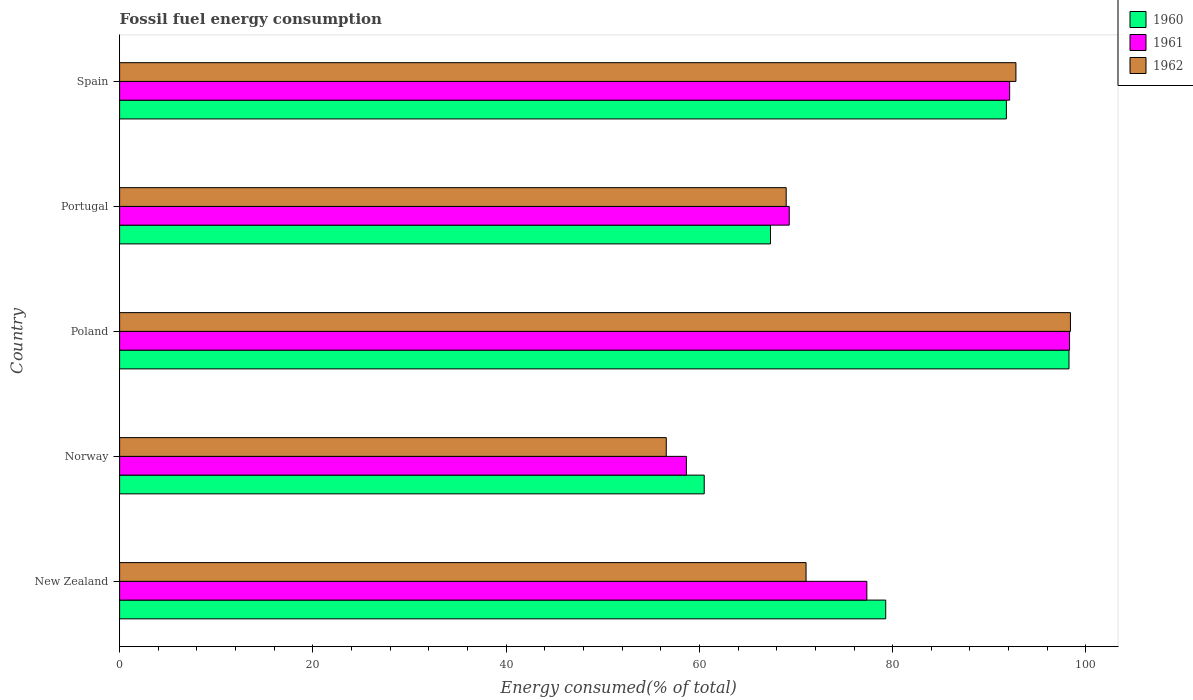How many different coloured bars are there?
Make the answer very short. 3. How many groups of bars are there?
Your answer should be compact. 5. Are the number of bars per tick equal to the number of legend labels?
Offer a terse response. Yes. How many bars are there on the 5th tick from the top?
Your answer should be very brief. 3. What is the label of the 1st group of bars from the top?
Keep it short and to the point. Spain. In how many cases, is the number of bars for a given country not equal to the number of legend labels?
Ensure brevity in your answer.  0. What is the percentage of energy consumed in 1961 in Norway?
Give a very brief answer. 58.65. Across all countries, what is the maximum percentage of energy consumed in 1962?
Your answer should be compact. 98.4. Across all countries, what is the minimum percentage of energy consumed in 1962?
Offer a terse response. 56.57. What is the total percentage of energy consumed in 1960 in the graph?
Provide a short and direct response. 397.15. What is the difference between the percentage of energy consumed in 1962 in New Zealand and that in Norway?
Provide a short and direct response. 14.47. What is the difference between the percentage of energy consumed in 1961 in Spain and the percentage of energy consumed in 1962 in Norway?
Provide a short and direct response. 35.53. What is the average percentage of energy consumed in 1962 per country?
Your answer should be compact. 77.55. What is the difference between the percentage of energy consumed in 1962 and percentage of energy consumed in 1961 in Norway?
Give a very brief answer. -2.08. What is the ratio of the percentage of energy consumed in 1962 in New Zealand to that in Spain?
Ensure brevity in your answer.  0.77. Is the difference between the percentage of energy consumed in 1962 in New Zealand and Norway greater than the difference between the percentage of energy consumed in 1961 in New Zealand and Norway?
Offer a very short reply. No. What is the difference between the highest and the second highest percentage of energy consumed in 1960?
Offer a very short reply. 6.48. What is the difference between the highest and the lowest percentage of energy consumed in 1962?
Make the answer very short. 41.83. In how many countries, is the percentage of energy consumed in 1962 greater than the average percentage of energy consumed in 1962 taken over all countries?
Make the answer very short. 2. What does the 3rd bar from the top in Norway represents?
Your answer should be very brief. 1960. What does the 1st bar from the bottom in Poland represents?
Offer a very short reply. 1960. Is it the case that in every country, the sum of the percentage of energy consumed in 1960 and percentage of energy consumed in 1962 is greater than the percentage of energy consumed in 1961?
Give a very brief answer. Yes. Are all the bars in the graph horizontal?
Give a very brief answer. Yes. How many countries are there in the graph?
Your response must be concise. 5. What is the difference between two consecutive major ticks on the X-axis?
Offer a very short reply. 20. Where does the legend appear in the graph?
Offer a very short reply. Top right. What is the title of the graph?
Keep it short and to the point. Fossil fuel energy consumption. Does "1974" appear as one of the legend labels in the graph?
Offer a very short reply. No. What is the label or title of the X-axis?
Keep it short and to the point. Energy consumed(% of total). What is the Energy consumed(% of total) of 1960 in New Zealand?
Make the answer very short. 79.28. What is the Energy consumed(% of total) in 1961 in New Zealand?
Provide a short and direct response. 77.33. What is the Energy consumed(% of total) of 1962 in New Zealand?
Provide a short and direct response. 71.04. What is the Energy consumed(% of total) in 1960 in Norway?
Your answer should be very brief. 60.5. What is the Energy consumed(% of total) of 1961 in Norway?
Ensure brevity in your answer.  58.65. What is the Energy consumed(% of total) in 1962 in Norway?
Your answer should be compact. 56.57. What is the Energy consumed(% of total) in 1960 in Poland?
Ensure brevity in your answer.  98.25. What is the Energy consumed(% of total) in 1961 in Poland?
Provide a short and direct response. 98.3. What is the Energy consumed(% of total) of 1962 in Poland?
Provide a short and direct response. 98.4. What is the Energy consumed(% of total) in 1960 in Portugal?
Ensure brevity in your answer.  67.36. What is the Energy consumed(% of total) of 1961 in Portugal?
Keep it short and to the point. 69.3. What is the Energy consumed(% of total) in 1962 in Portugal?
Offer a very short reply. 68.98. What is the Energy consumed(% of total) in 1960 in Spain?
Ensure brevity in your answer.  91.77. What is the Energy consumed(% of total) of 1961 in Spain?
Keep it short and to the point. 92.1. What is the Energy consumed(% of total) of 1962 in Spain?
Offer a terse response. 92.75. Across all countries, what is the maximum Energy consumed(% of total) in 1960?
Keep it short and to the point. 98.25. Across all countries, what is the maximum Energy consumed(% of total) in 1961?
Give a very brief answer. 98.3. Across all countries, what is the maximum Energy consumed(% of total) in 1962?
Provide a succinct answer. 98.4. Across all countries, what is the minimum Energy consumed(% of total) in 1960?
Offer a terse response. 60.5. Across all countries, what is the minimum Energy consumed(% of total) in 1961?
Provide a succinct answer. 58.65. Across all countries, what is the minimum Energy consumed(% of total) in 1962?
Make the answer very short. 56.57. What is the total Energy consumed(% of total) in 1960 in the graph?
Provide a short and direct response. 397.14. What is the total Energy consumed(% of total) in 1961 in the graph?
Offer a very short reply. 395.68. What is the total Energy consumed(% of total) in 1962 in the graph?
Provide a succinct answer. 387.74. What is the difference between the Energy consumed(% of total) in 1960 in New Zealand and that in Norway?
Offer a terse response. 18.78. What is the difference between the Energy consumed(% of total) in 1961 in New Zealand and that in Norway?
Your response must be concise. 18.68. What is the difference between the Energy consumed(% of total) of 1962 in New Zealand and that in Norway?
Offer a terse response. 14.47. What is the difference between the Energy consumed(% of total) of 1960 in New Zealand and that in Poland?
Offer a terse response. -18.97. What is the difference between the Energy consumed(% of total) in 1961 in New Zealand and that in Poland?
Offer a very short reply. -20.98. What is the difference between the Energy consumed(% of total) of 1962 in New Zealand and that in Poland?
Give a very brief answer. -27.36. What is the difference between the Energy consumed(% of total) in 1960 in New Zealand and that in Portugal?
Your response must be concise. 11.92. What is the difference between the Energy consumed(% of total) of 1961 in New Zealand and that in Portugal?
Ensure brevity in your answer.  8.03. What is the difference between the Energy consumed(% of total) of 1962 in New Zealand and that in Portugal?
Make the answer very short. 2.06. What is the difference between the Energy consumed(% of total) of 1960 in New Zealand and that in Spain?
Provide a short and direct response. -12.49. What is the difference between the Energy consumed(% of total) of 1961 in New Zealand and that in Spain?
Give a very brief answer. -14.78. What is the difference between the Energy consumed(% of total) of 1962 in New Zealand and that in Spain?
Provide a short and direct response. -21.72. What is the difference between the Energy consumed(% of total) of 1960 in Norway and that in Poland?
Your response must be concise. -37.75. What is the difference between the Energy consumed(% of total) of 1961 in Norway and that in Poland?
Your response must be concise. -39.65. What is the difference between the Energy consumed(% of total) of 1962 in Norway and that in Poland?
Offer a terse response. -41.83. What is the difference between the Energy consumed(% of total) in 1960 in Norway and that in Portugal?
Keep it short and to the point. -6.86. What is the difference between the Energy consumed(% of total) of 1961 in Norway and that in Portugal?
Provide a short and direct response. -10.64. What is the difference between the Energy consumed(% of total) of 1962 in Norway and that in Portugal?
Your answer should be very brief. -12.41. What is the difference between the Energy consumed(% of total) of 1960 in Norway and that in Spain?
Give a very brief answer. -31.27. What is the difference between the Energy consumed(% of total) of 1961 in Norway and that in Spain?
Make the answer very short. -33.45. What is the difference between the Energy consumed(% of total) of 1962 in Norway and that in Spain?
Ensure brevity in your answer.  -36.18. What is the difference between the Energy consumed(% of total) in 1960 in Poland and that in Portugal?
Offer a terse response. 30.89. What is the difference between the Energy consumed(% of total) of 1961 in Poland and that in Portugal?
Your response must be concise. 29.01. What is the difference between the Energy consumed(% of total) in 1962 in Poland and that in Portugal?
Your answer should be very brief. 29.42. What is the difference between the Energy consumed(% of total) of 1960 in Poland and that in Spain?
Provide a succinct answer. 6.48. What is the difference between the Energy consumed(% of total) in 1961 in Poland and that in Spain?
Provide a short and direct response. 6.2. What is the difference between the Energy consumed(% of total) of 1962 in Poland and that in Spain?
Make the answer very short. 5.64. What is the difference between the Energy consumed(% of total) of 1960 in Portugal and that in Spain?
Ensure brevity in your answer.  -24.41. What is the difference between the Energy consumed(% of total) of 1961 in Portugal and that in Spain?
Make the answer very short. -22.81. What is the difference between the Energy consumed(% of total) in 1962 in Portugal and that in Spain?
Your response must be concise. -23.77. What is the difference between the Energy consumed(% of total) of 1960 in New Zealand and the Energy consumed(% of total) of 1961 in Norway?
Your response must be concise. 20.63. What is the difference between the Energy consumed(% of total) in 1960 in New Zealand and the Energy consumed(% of total) in 1962 in Norway?
Your response must be concise. 22.71. What is the difference between the Energy consumed(% of total) in 1961 in New Zealand and the Energy consumed(% of total) in 1962 in Norway?
Ensure brevity in your answer.  20.76. What is the difference between the Energy consumed(% of total) of 1960 in New Zealand and the Energy consumed(% of total) of 1961 in Poland?
Give a very brief answer. -19.02. What is the difference between the Energy consumed(% of total) in 1960 in New Zealand and the Energy consumed(% of total) in 1962 in Poland?
Offer a terse response. -19.12. What is the difference between the Energy consumed(% of total) in 1961 in New Zealand and the Energy consumed(% of total) in 1962 in Poland?
Offer a very short reply. -21.07. What is the difference between the Energy consumed(% of total) in 1960 in New Zealand and the Energy consumed(% of total) in 1961 in Portugal?
Give a very brief answer. 9.98. What is the difference between the Energy consumed(% of total) of 1960 in New Zealand and the Energy consumed(% of total) of 1962 in Portugal?
Give a very brief answer. 10.3. What is the difference between the Energy consumed(% of total) of 1961 in New Zealand and the Energy consumed(% of total) of 1962 in Portugal?
Keep it short and to the point. 8.35. What is the difference between the Energy consumed(% of total) of 1960 in New Zealand and the Energy consumed(% of total) of 1961 in Spain?
Your answer should be compact. -12.83. What is the difference between the Energy consumed(% of total) in 1960 in New Zealand and the Energy consumed(% of total) in 1962 in Spain?
Offer a very short reply. -13.47. What is the difference between the Energy consumed(% of total) in 1961 in New Zealand and the Energy consumed(% of total) in 1962 in Spain?
Make the answer very short. -15.43. What is the difference between the Energy consumed(% of total) in 1960 in Norway and the Energy consumed(% of total) in 1961 in Poland?
Your answer should be compact. -37.81. What is the difference between the Energy consumed(% of total) in 1960 in Norway and the Energy consumed(% of total) in 1962 in Poland?
Your answer should be compact. -37.9. What is the difference between the Energy consumed(% of total) of 1961 in Norway and the Energy consumed(% of total) of 1962 in Poland?
Offer a very short reply. -39.74. What is the difference between the Energy consumed(% of total) of 1960 in Norway and the Energy consumed(% of total) of 1961 in Portugal?
Provide a succinct answer. -8.8. What is the difference between the Energy consumed(% of total) of 1960 in Norway and the Energy consumed(% of total) of 1962 in Portugal?
Make the answer very short. -8.48. What is the difference between the Energy consumed(% of total) of 1961 in Norway and the Energy consumed(% of total) of 1962 in Portugal?
Provide a succinct answer. -10.33. What is the difference between the Energy consumed(% of total) of 1960 in Norway and the Energy consumed(% of total) of 1961 in Spain?
Give a very brief answer. -31.61. What is the difference between the Energy consumed(% of total) of 1960 in Norway and the Energy consumed(% of total) of 1962 in Spain?
Provide a short and direct response. -32.26. What is the difference between the Energy consumed(% of total) in 1961 in Norway and the Energy consumed(% of total) in 1962 in Spain?
Your answer should be very brief. -34.1. What is the difference between the Energy consumed(% of total) of 1960 in Poland and the Energy consumed(% of total) of 1961 in Portugal?
Give a very brief answer. 28.95. What is the difference between the Energy consumed(% of total) of 1960 in Poland and the Energy consumed(% of total) of 1962 in Portugal?
Your answer should be compact. 29.27. What is the difference between the Energy consumed(% of total) of 1961 in Poland and the Energy consumed(% of total) of 1962 in Portugal?
Your answer should be compact. 29.32. What is the difference between the Energy consumed(% of total) of 1960 in Poland and the Energy consumed(% of total) of 1961 in Spain?
Offer a very short reply. 6.14. What is the difference between the Energy consumed(% of total) of 1960 in Poland and the Energy consumed(% of total) of 1962 in Spain?
Give a very brief answer. 5.49. What is the difference between the Energy consumed(% of total) of 1961 in Poland and the Energy consumed(% of total) of 1962 in Spain?
Offer a very short reply. 5.55. What is the difference between the Energy consumed(% of total) of 1960 in Portugal and the Energy consumed(% of total) of 1961 in Spain?
Offer a terse response. -24.75. What is the difference between the Energy consumed(% of total) in 1960 in Portugal and the Energy consumed(% of total) in 1962 in Spain?
Provide a short and direct response. -25.4. What is the difference between the Energy consumed(% of total) in 1961 in Portugal and the Energy consumed(% of total) in 1962 in Spain?
Your response must be concise. -23.46. What is the average Energy consumed(% of total) in 1960 per country?
Keep it short and to the point. 79.43. What is the average Energy consumed(% of total) of 1961 per country?
Your answer should be compact. 79.14. What is the average Energy consumed(% of total) in 1962 per country?
Give a very brief answer. 77.55. What is the difference between the Energy consumed(% of total) in 1960 and Energy consumed(% of total) in 1961 in New Zealand?
Your response must be concise. 1.95. What is the difference between the Energy consumed(% of total) of 1960 and Energy consumed(% of total) of 1962 in New Zealand?
Offer a terse response. 8.24. What is the difference between the Energy consumed(% of total) of 1961 and Energy consumed(% of total) of 1962 in New Zealand?
Your answer should be very brief. 6.29. What is the difference between the Energy consumed(% of total) of 1960 and Energy consumed(% of total) of 1961 in Norway?
Offer a very short reply. 1.85. What is the difference between the Energy consumed(% of total) of 1960 and Energy consumed(% of total) of 1962 in Norway?
Give a very brief answer. 3.93. What is the difference between the Energy consumed(% of total) in 1961 and Energy consumed(% of total) in 1962 in Norway?
Keep it short and to the point. 2.08. What is the difference between the Energy consumed(% of total) in 1960 and Energy consumed(% of total) in 1961 in Poland?
Make the answer very short. -0.06. What is the difference between the Energy consumed(% of total) in 1960 and Energy consumed(% of total) in 1962 in Poland?
Give a very brief answer. -0.15. What is the difference between the Energy consumed(% of total) in 1961 and Energy consumed(% of total) in 1962 in Poland?
Keep it short and to the point. -0.09. What is the difference between the Energy consumed(% of total) of 1960 and Energy consumed(% of total) of 1961 in Portugal?
Your answer should be compact. -1.94. What is the difference between the Energy consumed(% of total) of 1960 and Energy consumed(% of total) of 1962 in Portugal?
Offer a terse response. -1.62. What is the difference between the Energy consumed(% of total) in 1961 and Energy consumed(% of total) in 1962 in Portugal?
Make the answer very short. 0.32. What is the difference between the Energy consumed(% of total) in 1960 and Energy consumed(% of total) in 1961 in Spain?
Offer a very short reply. -0.34. What is the difference between the Energy consumed(% of total) in 1960 and Energy consumed(% of total) in 1962 in Spain?
Provide a short and direct response. -0.99. What is the difference between the Energy consumed(% of total) of 1961 and Energy consumed(% of total) of 1962 in Spain?
Your response must be concise. -0.65. What is the ratio of the Energy consumed(% of total) in 1960 in New Zealand to that in Norway?
Offer a very short reply. 1.31. What is the ratio of the Energy consumed(% of total) of 1961 in New Zealand to that in Norway?
Make the answer very short. 1.32. What is the ratio of the Energy consumed(% of total) in 1962 in New Zealand to that in Norway?
Your answer should be compact. 1.26. What is the ratio of the Energy consumed(% of total) of 1960 in New Zealand to that in Poland?
Your answer should be very brief. 0.81. What is the ratio of the Energy consumed(% of total) in 1961 in New Zealand to that in Poland?
Ensure brevity in your answer.  0.79. What is the ratio of the Energy consumed(% of total) of 1962 in New Zealand to that in Poland?
Provide a succinct answer. 0.72. What is the ratio of the Energy consumed(% of total) in 1960 in New Zealand to that in Portugal?
Offer a very short reply. 1.18. What is the ratio of the Energy consumed(% of total) of 1961 in New Zealand to that in Portugal?
Offer a terse response. 1.12. What is the ratio of the Energy consumed(% of total) in 1962 in New Zealand to that in Portugal?
Your answer should be very brief. 1.03. What is the ratio of the Energy consumed(% of total) of 1960 in New Zealand to that in Spain?
Your response must be concise. 0.86. What is the ratio of the Energy consumed(% of total) of 1961 in New Zealand to that in Spain?
Offer a very short reply. 0.84. What is the ratio of the Energy consumed(% of total) of 1962 in New Zealand to that in Spain?
Make the answer very short. 0.77. What is the ratio of the Energy consumed(% of total) of 1960 in Norway to that in Poland?
Ensure brevity in your answer.  0.62. What is the ratio of the Energy consumed(% of total) of 1961 in Norway to that in Poland?
Your answer should be very brief. 0.6. What is the ratio of the Energy consumed(% of total) in 1962 in Norway to that in Poland?
Offer a terse response. 0.57. What is the ratio of the Energy consumed(% of total) of 1960 in Norway to that in Portugal?
Provide a short and direct response. 0.9. What is the ratio of the Energy consumed(% of total) in 1961 in Norway to that in Portugal?
Keep it short and to the point. 0.85. What is the ratio of the Energy consumed(% of total) of 1962 in Norway to that in Portugal?
Offer a very short reply. 0.82. What is the ratio of the Energy consumed(% of total) in 1960 in Norway to that in Spain?
Provide a succinct answer. 0.66. What is the ratio of the Energy consumed(% of total) in 1961 in Norway to that in Spain?
Make the answer very short. 0.64. What is the ratio of the Energy consumed(% of total) in 1962 in Norway to that in Spain?
Your answer should be very brief. 0.61. What is the ratio of the Energy consumed(% of total) of 1960 in Poland to that in Portugal?
Provide a succinct answer. 1.46. What is the ratio of the Energy consumed(% of total) in 1961 in Poland to that in Portugal?
Make the answer very short. 1.42. What is the ratio of the Energy consumed(% of total) in 1962 in Poland to that in Portugal?
Ensure brevity in your answer.  1.43. What is the ratio of the Energy consumed(% of total) in 1960 in Poland to that in Spain?
Offer a very short reply. 1.07. What is the ratio of the Energy consumed(% of total) of 1961 in Poland to that in Spain?
Make the answer very short. 1.07. What is the ratio of the Energy consumed(% of total) in 1962 in Poland to that in Spain?
Ensure brevity in your answer.  1.06. What is the ratio of the Energy consumed(% of total) in 1960 in Portugal to that in Spain?
Give a very brief answer. 0.73. What is the ratio of the Energy consumed(% of total) of 1961 in Portugal to that in Spain?
Provide a succinct answer. 0.75. What is the ratio of the Energy consumed(% of total) of 1962 in Portugal to that in Spain?
Keep it short and to the point. 0.74. What is the difference between the highest and the second highest Energy consumed(% of total) of 1960?
Provide a short and direct response. 6.48. What is the difference between the highest and the second highest Energy consumed(% of total) of 1961?
Offer a terse response. 6.2. What is the difference between the highest and the second highest Energy consumed(% of total) in 1962?
Give a very brief answer. 5.64. What is the difference between the highest and the lowest Energy consumed(% of total) in 1960?
Your answer should be very brief. 37.75. What is the difference between the highest and the lowest Energy consumed(% of total) of 1961?
Your answer should be very brief. 39.65. What is the difference between the highest and the lowest Energy consumed(% of total) in 1962?
Ensure brevity in your answer.  41.83. 